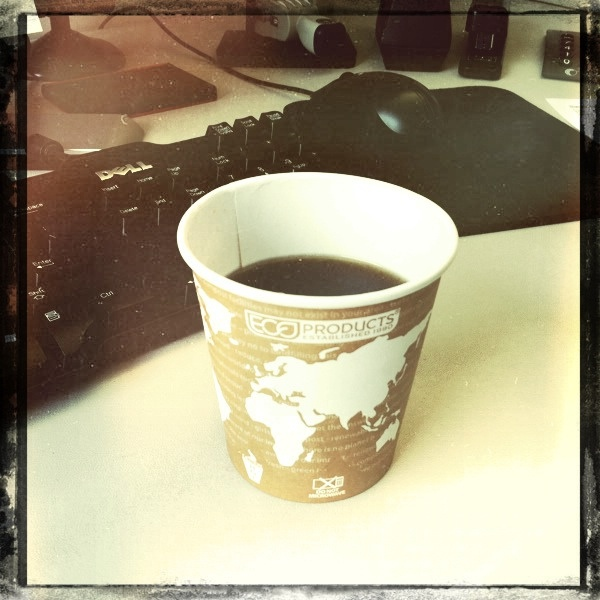Describe the objects in this image and their specific colors. I can see cup in darkgray, ivory, khaki, tan, and gray tones, keyboard in darkgray, maroon, black, and khaki tones, and mouse in darkgray and black tones in this image. 